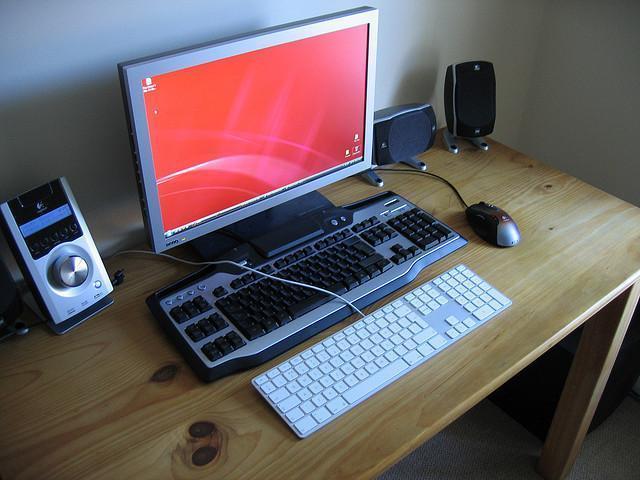How many keyboards are there?
Give a very brief answer. 2. How many people are eating a doughnut?
Give a very brief answer. 0. 